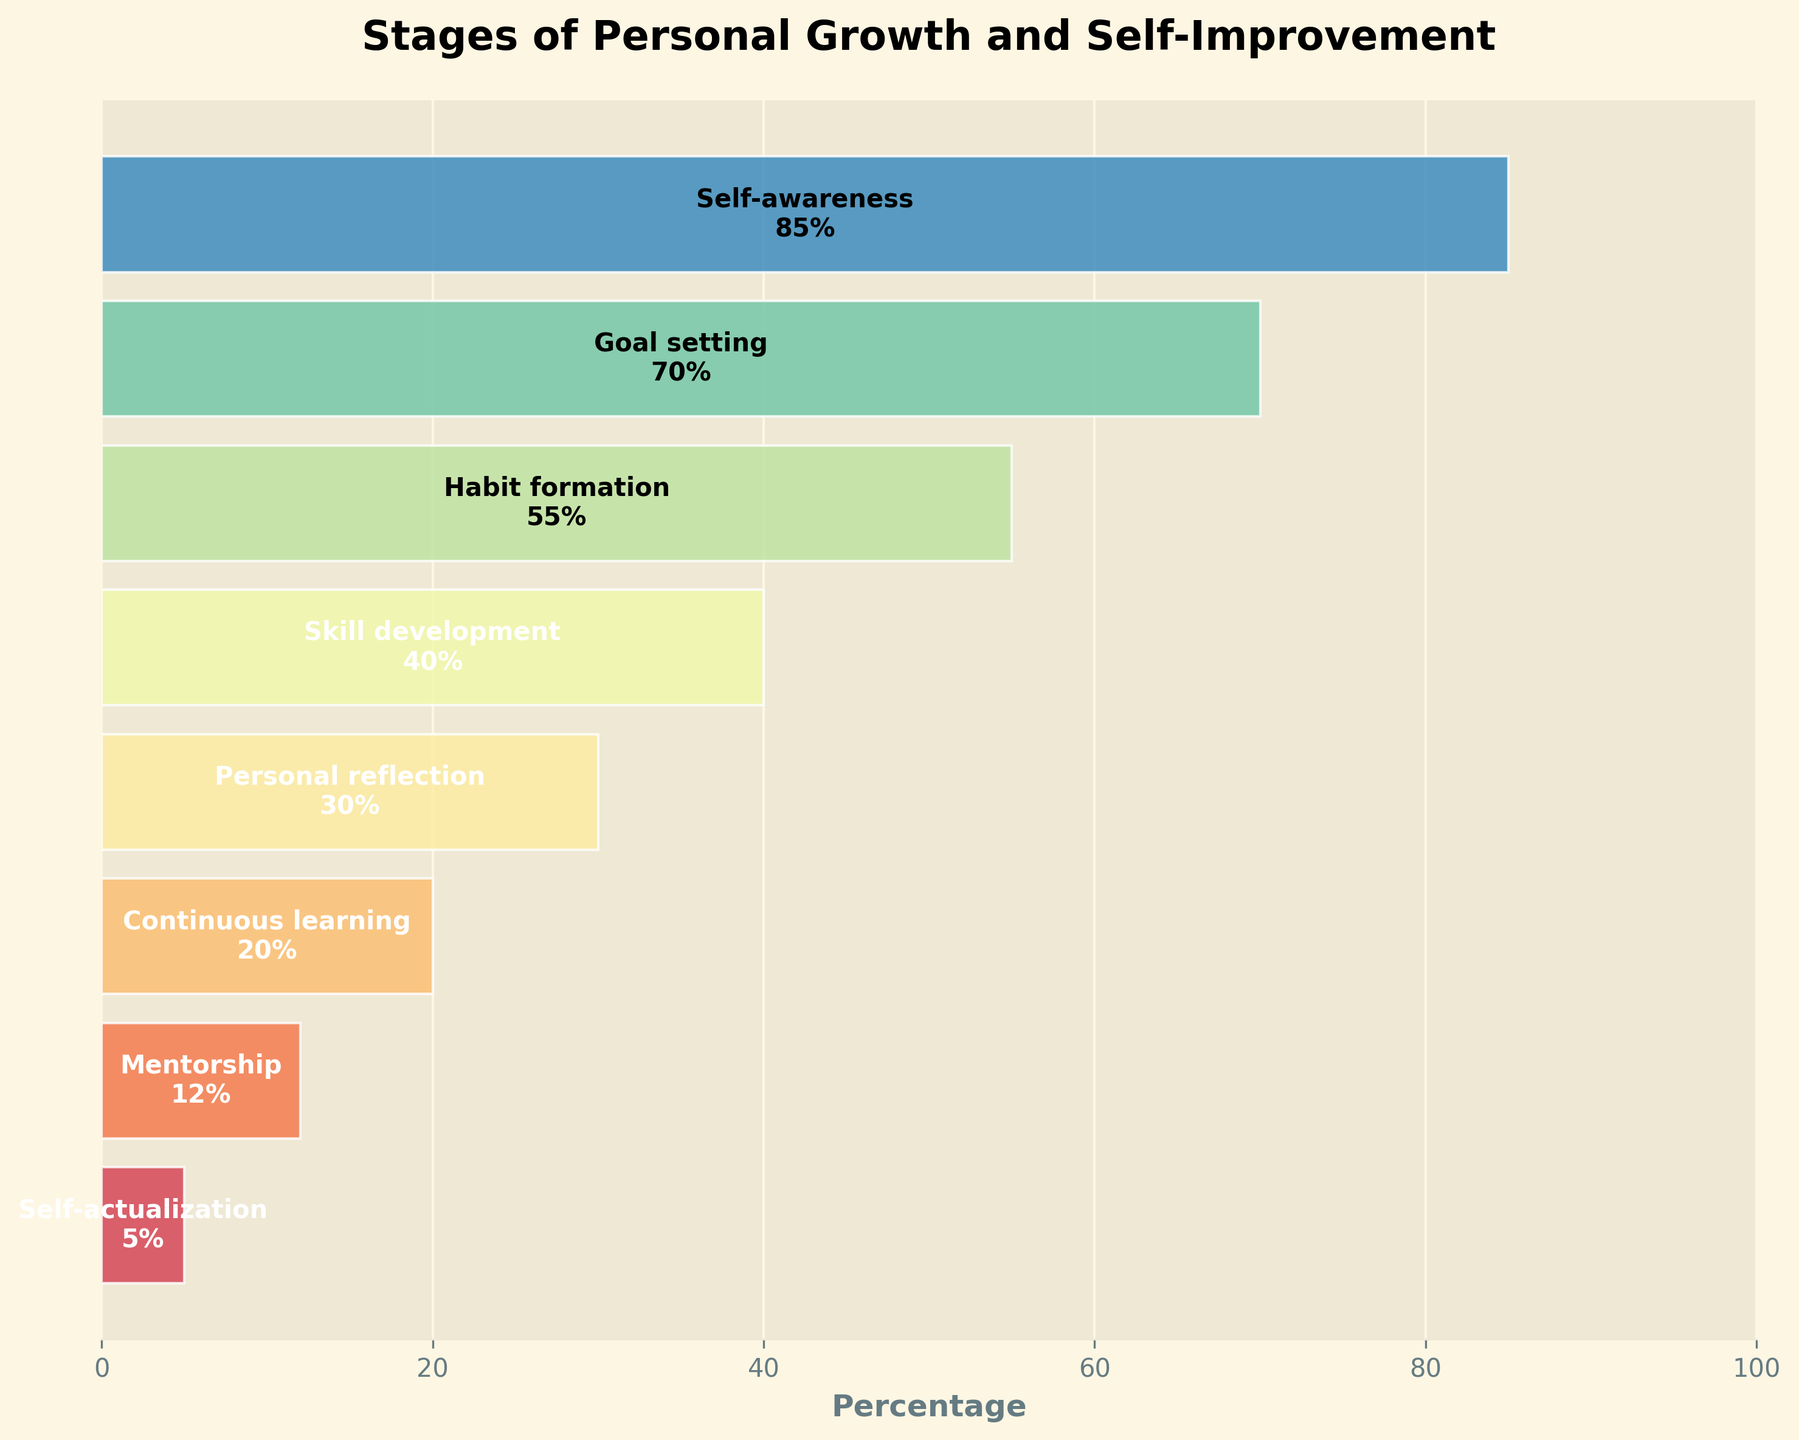What is the title of the chart? The title is usually found at the top of the chart and provides an overview of the content. In this case, you can read the title directly from the chart.
Answer: Stages of Personal Growth and Self-Improvement Which stage has the highest percentage? To find the stage with the highest percentage, look at the length of the bars in the funnel chart. The longest bar usually represents the highest percentage. In this chart, it's the top-most stage.
Answer: Self-awareness What is the percentage of individuals who reach 'Habit formation'? Identify the bar corresponding to 'Habit formation' and read the percentage displayed inside or next to the bar.
Answer: 55% Compare the percentages of 'Skill development' and 'Personal reflection'. Which stage has a higher percentage? Locate the bars for both 'Skill development' and 'Personal reflection' and compare their lengths or the numbers inside them.
Answer: Skill development What is the average percentage of individuals across all stages? Add up all the percentages and then divide the sum by the number of stages. (85 + 70 + 55 + 40 + 30 + 20 + 12 + 5) / 8 = 317 / 8 = 39.625
Answer: 39.625 How many stages are displayed in the funnel chart? Count the number of distinct bars or stages listed from top to bottom in the chart.
Answer: 8 Why might the percentage decrease from 'Self-awareness' to 'Self-actualization'? Consider that as individuals progress through stages of personal growth, each stage may require more commitment and effort, causing fewer individuals to reach the subsequent stages. More detailed reasoning involves understanding that personal growth is a complex and challenging journey where obstacles and varying levels of dedication impact progress.
Answer: The stages require increasing effort and commitment What is the percentage difference between 'Continuous learning' and 'Mentorship'? Subtract the percentage of 'Mentorship' from that of 'Continuous learning' to find the difference. 20% - 12% = 8%
Answer: 8% How does the percentage of 'Goal setting' compare to 'Habit formation'? Compare the lengths of their respective bars or their percentages directly. 'Goal setting' is 70% and 'Habit formation' is 55%.
Answer: Goal setting has a higher percentage What does the stage 'Self-actualization' represent in the context of this funnel chart? Consider that 'Self-actualization' is typically the ultimate stage in personal development frameworks, representing the achievement of one's full potential. In this chart, it likely indicates the final, most challenging level to reach. The low percentage (5%) implies that very few individuals reach this stage.
Answer: Achieving one's full potential and is the final stage 